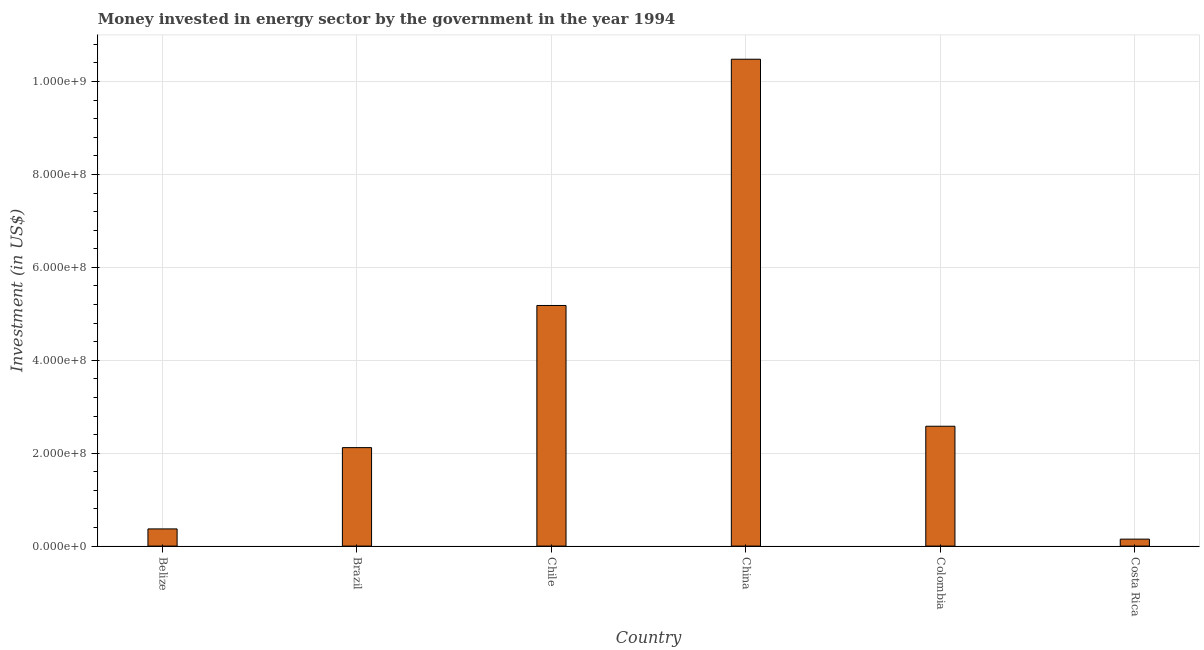Does the graph contain any zero values?
Your answer should be compact. No. What is the title of the graph?
Provide a succinct answer. Money invested in energy sector by the government in the year 1994. What is the label or title of the Y-axis?
Keep it short and to the point. Investment (in US$). What is the investment in energy in Brazil?
Keep it short and to the point. 2.12e+08. Across all countries, what is the maximum investment in energy?
Offer a very short reply. 1.05e+09. Across all countries, what is the minimum investment in energy?
Offer a terse response. 1.50e+07. In which country was the investment in energy maximum?
Offer a terse response. China. In which country was the investment in energy minimum?
Your response must be concise. Costa Rica. What is the sum of the investment in energy?
Give a very brief answer. 2.09e+09. What is the difference between the investment in energy in Colombia and Costa Rica?
Provide a succinct answer. 2.43e+08. What is the average investment in energy per country?
Your response must be concise. 3.48e+08. What is the median investment in energy?
Ensure brevity in your answer.  2.35e+08. What is the ratio of the investment in energy in Belize to that in Brazil?
Your answer should be compact. 0.17. Is the investment in energy in Chile less than that in China?
Your response must be concise. Yes. Is the difference between the investment in energy in Brazil and Chile greater than the difference between any two countries?
Offer a very short reply. No. What is the difference between the highest and the second highest investment in energy?
Offer a very short reply. 5.30e+08. What is the difference between the highest and the lowest investment in energy?
Offer a terse response. 1.03e+09. In how many countries, is the investment in energy greater than the average investment in energy taken over all countries?
Provide a succinct answer. 2. Are all the bars in the graph horizontal?
Keep it short and to the point. No. What is the difference between two consecutive major ticks on the Y-axis?
Your answer should be compact. 2.00e+08. Are the values on the major ticks of Y-axis written in scientific E-notation?
Offer a terse response. Yes. What is the Investment (in US$) in Belize?
Your answer should be compact. 3.70e+07. What is the Investment (in US$) of Brazil?
Your answer should be compact. 2.12e+08. What is the Investment (in US$) of Chile?
Provide a succinct answer. 5.18e+08. What is the Investment (in US$) of China?
Your answer should be very brief. 1.05e+09. What is the Investment (in US$) of Colombia?
Provide a short and direct response. 2.58e+08. What is the Investment (in US$) of Costa Rica?
Offer a very short reply. 1.50e+07. What is the difference between the Investment (in US$) in Belize and Brazil?
Keep it short and to the point. -1.75e+08. What is the difference between the Investment (in US$) in Belize and Chile?
Your response must be concise. -4.81e+08. What is the difference between the Investment (in US$) in Belize and China?
Your response must be concise. -1.01e+09. What is the difference between the Investment (in US$) in Belize and Colombia?
Provide a succinct answer. -2.21e+08. What is the difference between the Investment (in US$) in Belize and Costa Rica?
Give a very brief answer. 2.20e+07. What is the difference between the Investment (in US$) in Brazil and Chile?
Give a very brief answer. -3.06e+08. What is the difference between the Investment (in US$) in Brazil and China?
Make the answer very short. -8.36e+08. What is the difference between the Investment (in US$) in Brazil and Colombia?
Offer a very short reply. -4.60e+07. What is the difference between the Investment (in US$) in Brazil and Costa Rica?
Your answer should be compact. 1.97e+08. What is the difference between the Investment (in US$) in Chile and China?
Your answer should be compact. -5.30e+08. What is the difference between the Investment (in US$) in Chile and Colombia?
Provide a short and direct response. 2.60e+08. What is the difference between the Investment (in US$) in Chile and Costa Rica?
Give a very brief answer. 5.03e+08. What is the difference between the Investment (in US$) in China and Colombia?
Offer a very short reply. 7.90e+08. What is the difference between the Investment (in US$) in China and Costa Rica?
Make the answer very short. 1.03e+09. What is the difference between the Investment (in US$) in Colombia and Costa Rica?
Offer a terse response. 2.43e+08. What is the ratio of the Investment (in US$) in Belize to that in Brazil?
Ensure brevity in your answer.  0.17. What is the ratio of the Investment (in US$) in Belize to that in Chile?
Ensure brevity in your answer.  0.07. What is the ratio of the Investment (in US$) in Belize to that in China?
Make the answer very short. 0.04. What is the ratio of the Investment (in US$) in Belize to that in Colombia?
Your answer should be very brief. 0.14. What is the ratio of the Investment (in US$) in Belize to that in Costa Rica?
Keep it short and to the point. 2.47. What is the ratio of the Investment (in US$) in Brazil to that in Chile?
Your answer should be very brief. 0.41. What is the ratio of the Investment (in US$) in Brazil to that in China?
Keep it short and to the point. 0.2. What is the ratio of the Investment (in US$) in Brazil to that in Colombia?
Provide a succinct answer. 0.82. What is the ratio of the Investment (in US$) in Brazil to that in Costa Rica?
Provide a succinct answer. 14.13. What is the ratio of the Investment (in US$) in Chile to that in China?
Provide a short and direct response. 0.49. What is the ratio of the Investment (in US$) in Chile to that in Colombia?
Provide a succinct answer. 2.01. What is the ratio of the Investment (in US$) in Chile to that in Costa Rica?
Your answer should be compact. 34.53. What is the ratio of the Investment (in US$) in China to that in Colombia?
Offer a very short reply. 4.06. What is the ratio of the Investment (in US$) in China to that in Costa Rica?
Ensure brevity in your answer.  69.87. 